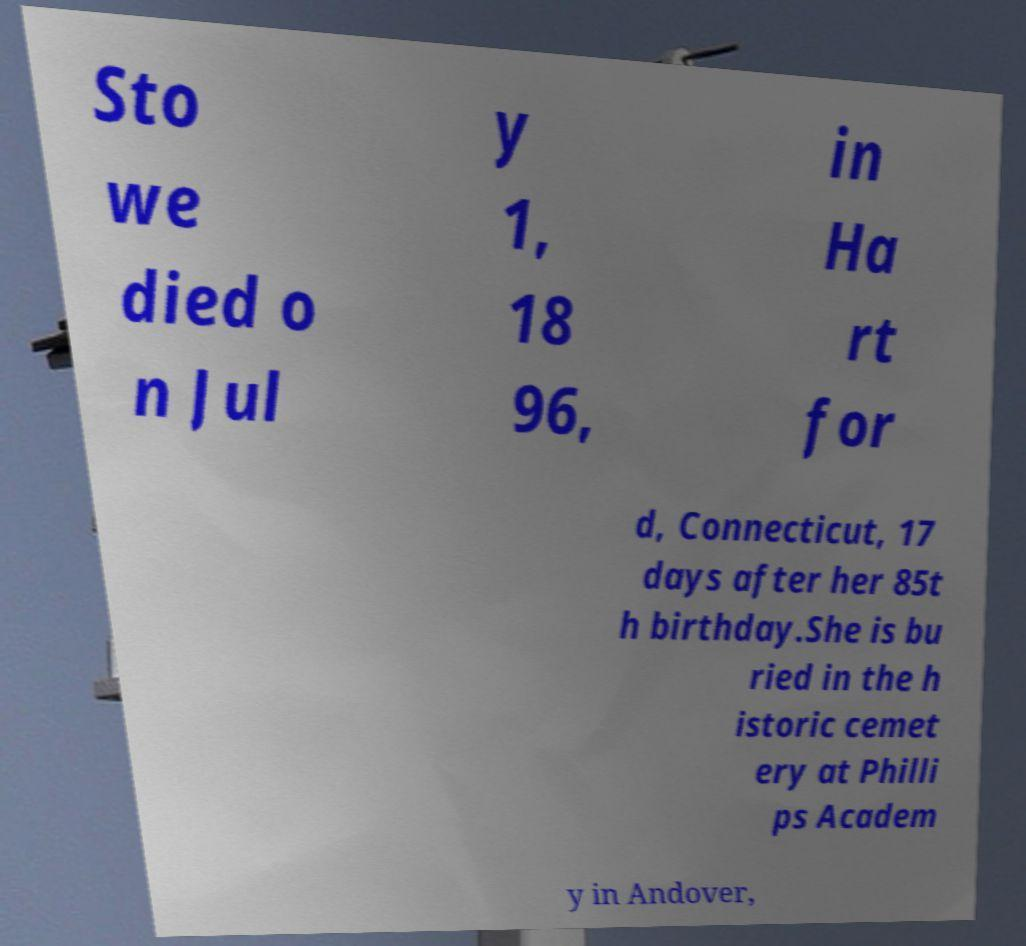Could you assist in decoding the text presented in this image and type it out clearly? Sto we died o n Jul y 1, 18 96, in Ha rt for d, Connecticut, 17 days after her 85t h birthday.She is bu ried in the h istoric cemet ery at Philli ps Academ y in Andover, 